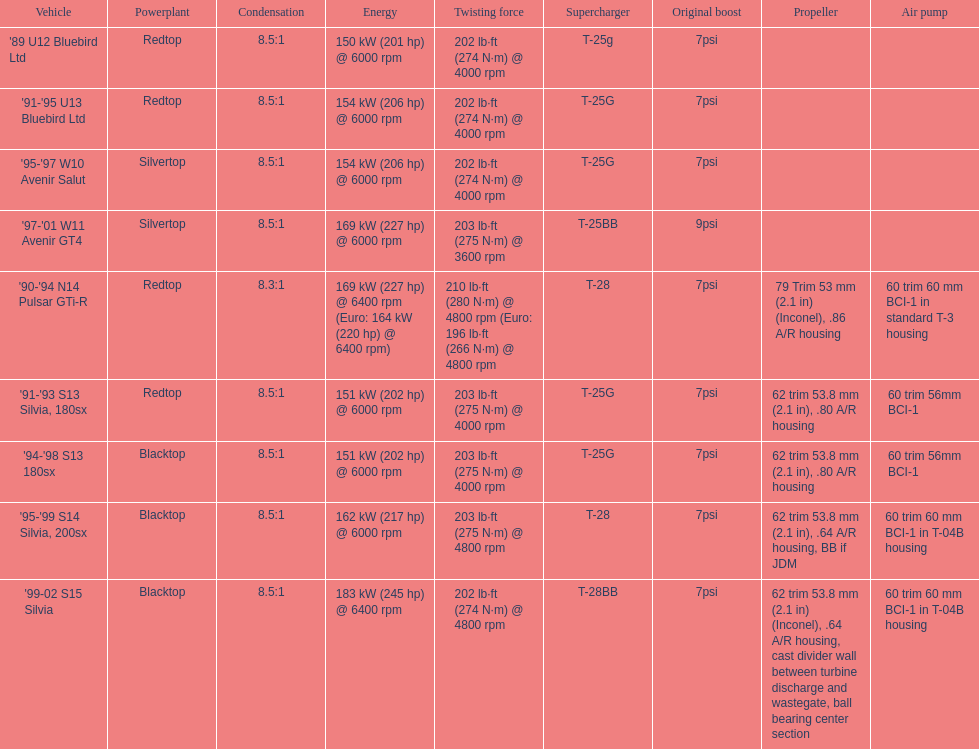Which car has a stock boost of over 7psi? '97-'01 W11 Avenir GT4. 